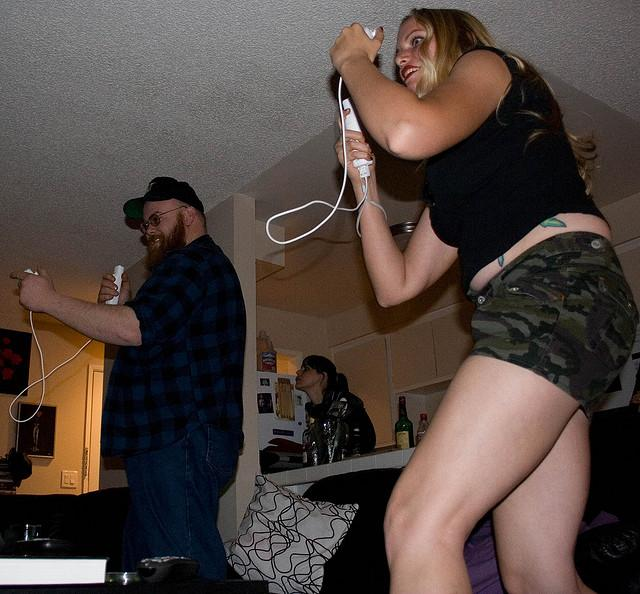What video game console is being played by the two people in front? Please explain your reasoning. nintendo wii. Two people stand in front of a television with white controllers in both hands. 